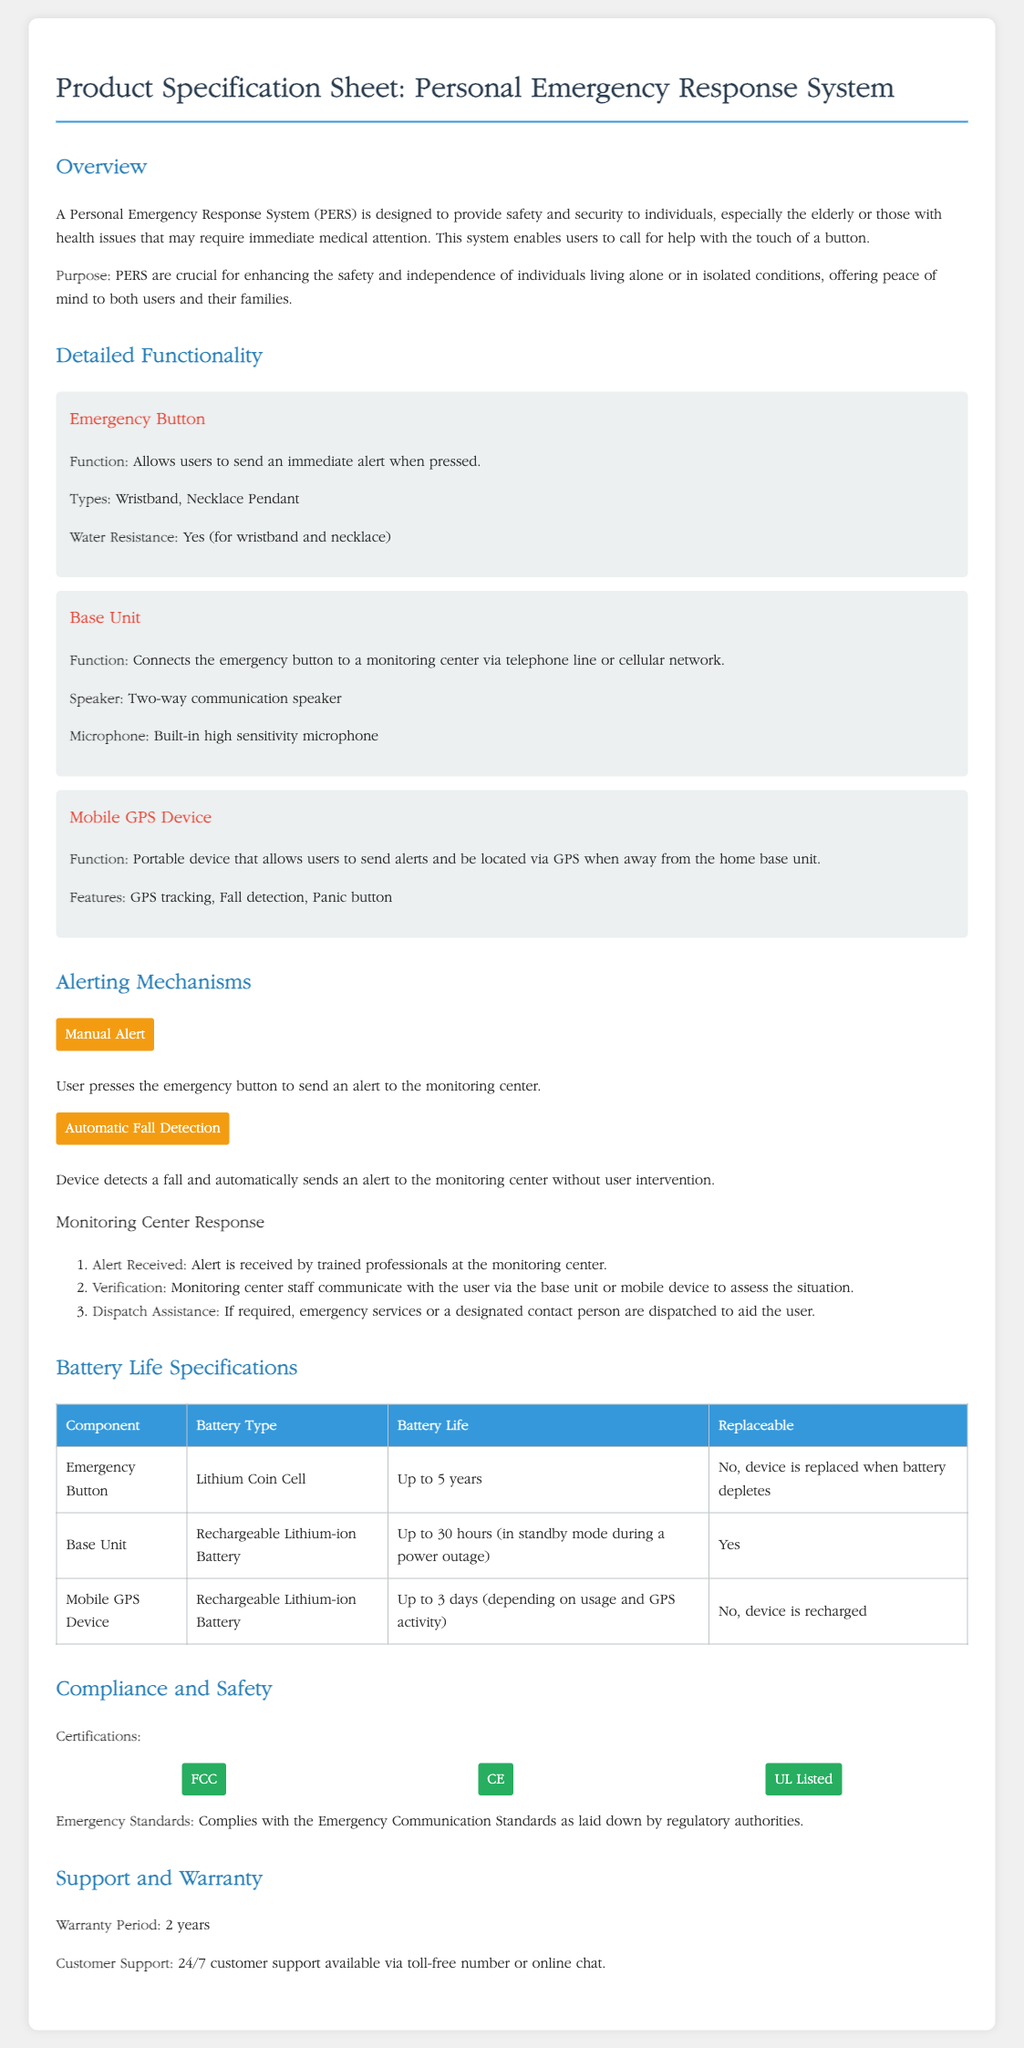what is the maximum battery life of the emergency button? The maximum battery life of the emergency button is stated in the battery specifications as up to 5 years.
Answer: up to 5 years what type of battery does the base unit use? The document specifies that the base unit uses a rechargeable lithium-ion battery.
Answer: rechargeable lithium-ion battery how long does the mobile GPS device last on a single charge? The document mentions that the mobile GPS device can last up to 3 days depending on usage and GPS activity.
Answer: up to 3 days what are the two types of emergency buttons mentioned? The document lists wristband and necklace pendant as the two types of emergency buttons.
Answer: wristband, necklace pendant what does the compliance section mention as certifications? The compliance section lists FCC, CE, and UL Listed as certifications for the device.
Answer: FCC, CE, UL Listed how is an alert sent manually? The document explains that an alert is sent when the user presses the emergency button.
Answer: pressing the emergency button what feature allows the mobile GPS device to locate users? The document specifies that GPS tracking is the feature enabling the mobile GPS device to locate users.
Answer: GPS tracking what does the warranty period for the system specify? The warranty period for the system is clearly stated as 2 years in the support section.
Answer: 2 years 